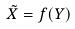Convert formula to latex. <formula><loc_0><loc_0><loc_500><loc_500>\tilde { X } = f ( Y )</formula> 